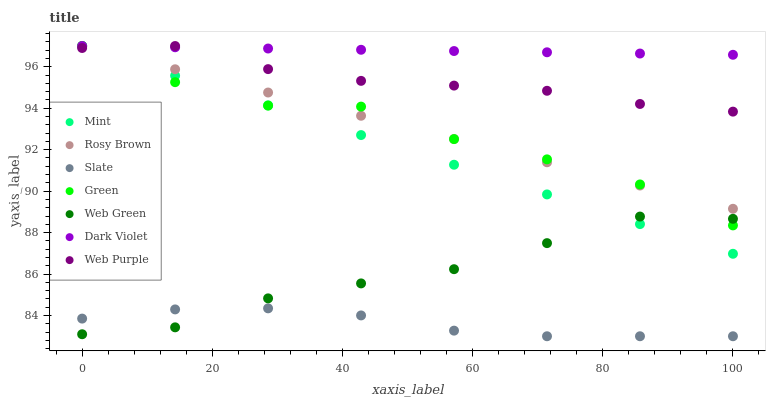Does Slate have the minimum area under the curve?
Answer yes or no. Yes. Does Dark Violet have the maximum area under the curve?
Answer yes or no. Yes. Does Rosy Brown have the minimum area under the curve?
Answer yes or no. No. Does Rosy Brown have the maximum area under the curve?
Answer yes or no. No. Is Dark Violet the smoothest?
Answer yes or no. Yes. Is Green the roughest?
Answer yes or no. Yes. Is Rosy Brown the smoothest?
Answer yes or no. No. Is Rosy Brown the roughest?
Answer yes or no. No. Does Slate have the lowest value?
Answer yes or no. Yes. Does Rosy Brown have the lowest value?
Answer yes or no. No. Does Mint have the highest value?
Answer yes or no. Yes. Does Web Green have the highest value?
Answer yes or no. No. Is Web Green less than Rosy Brown?
Answer yes or no. Yes. Is Green greater than Slate?
Answer yes or no. Yes. Does Mint intersect Green?
Answer yes or no. Yes. Is Mint less than Green?
Answer yes or no. No. Is Mint greater than Green?
Answer yes or no. No. Does Web Green intersect Rosy Brown?
Answer yes or no. No. 